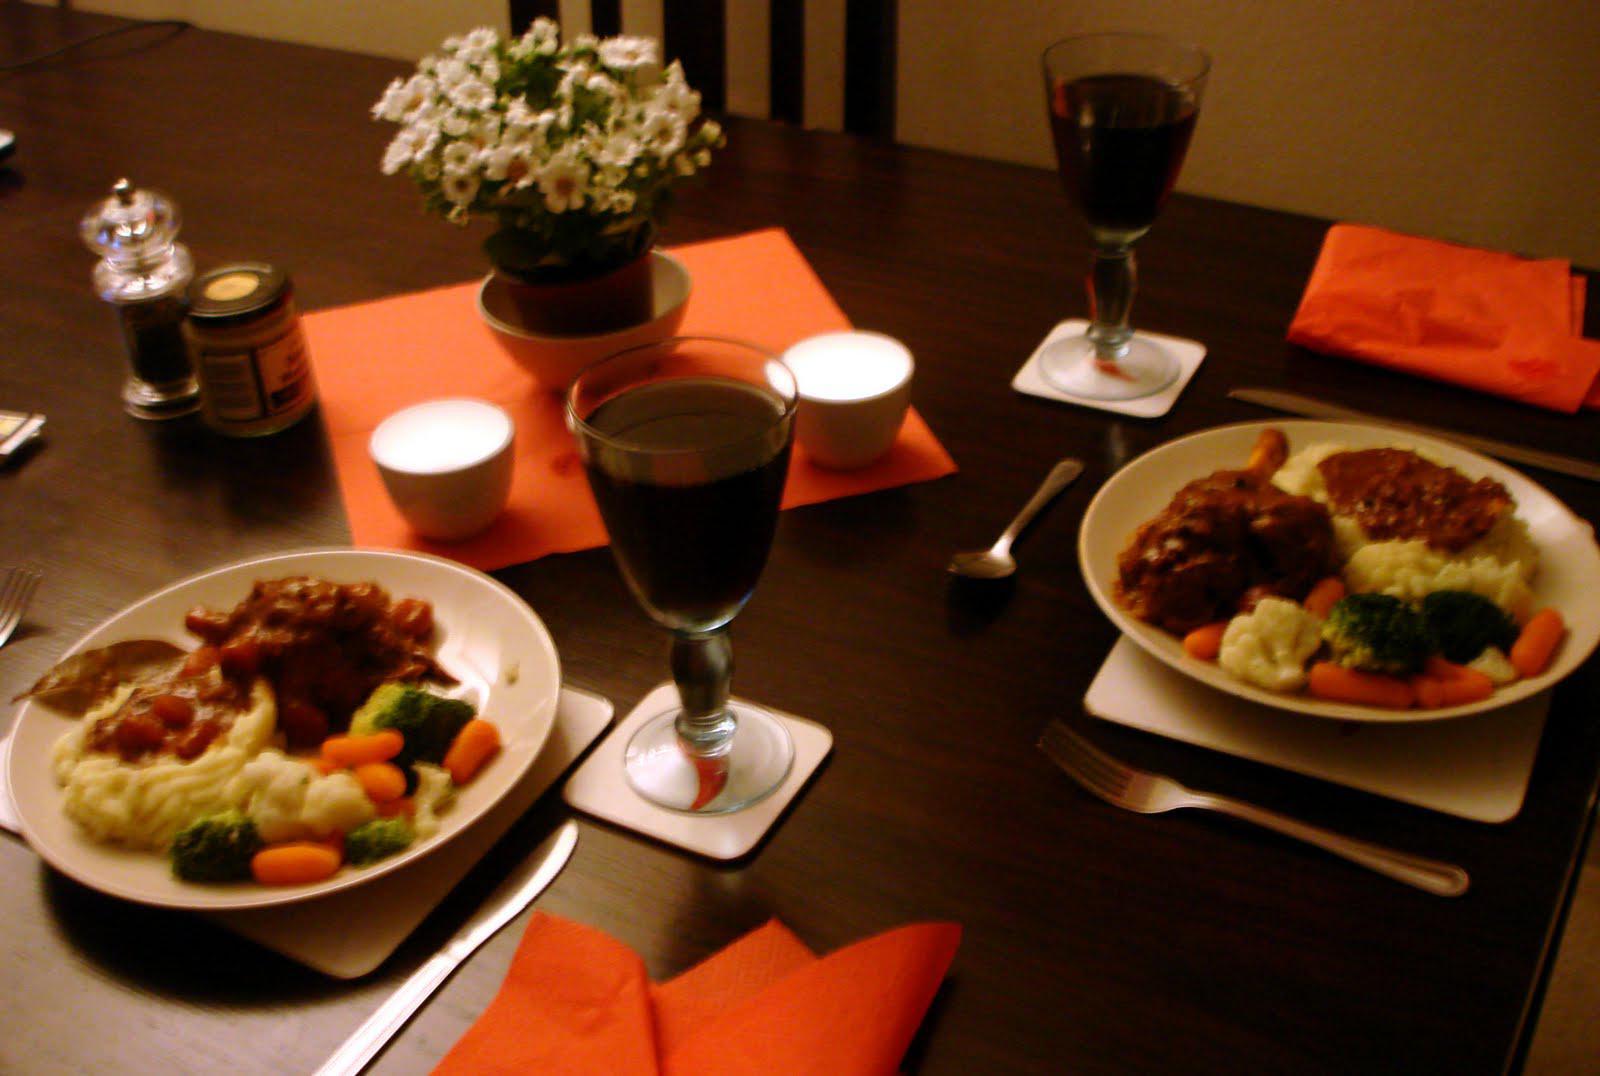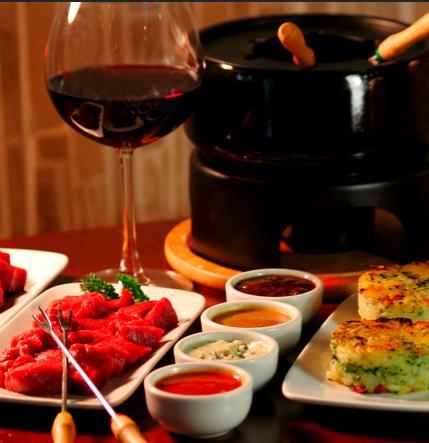The first image is the image on the left, the second image is the image on the right. Given the left and right images, does the statement "Left image shows a table holding exactly two glasses, which contain dark wine." hold true? Answer yes or no. Yes. The first image is the image on the left, the second image is the image on the right. For the images shown, is this caption "The table in the image on the left has a white table cloth." true? Answer yes or no. No. 